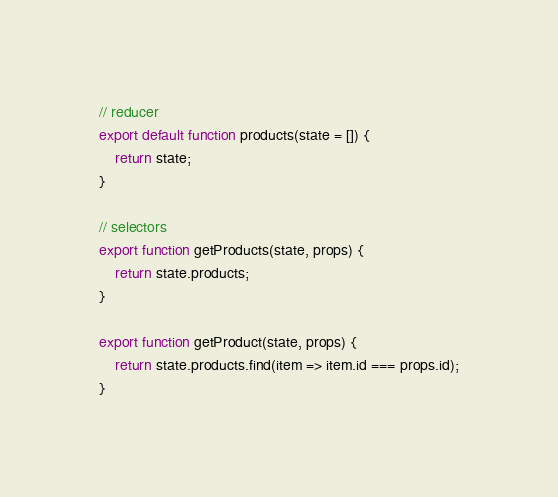<code> <loc_0><loc_0><loc_500><loc_500><_JavaScript_>// reducer
export default function products(state = []) {
    return state;
}

// selectors
export function getProducts(state, props) {
    return state.products;
}

export function getProduct(state, props) {
    return state.products.find(item => item.id === props.id);
}
</code> 